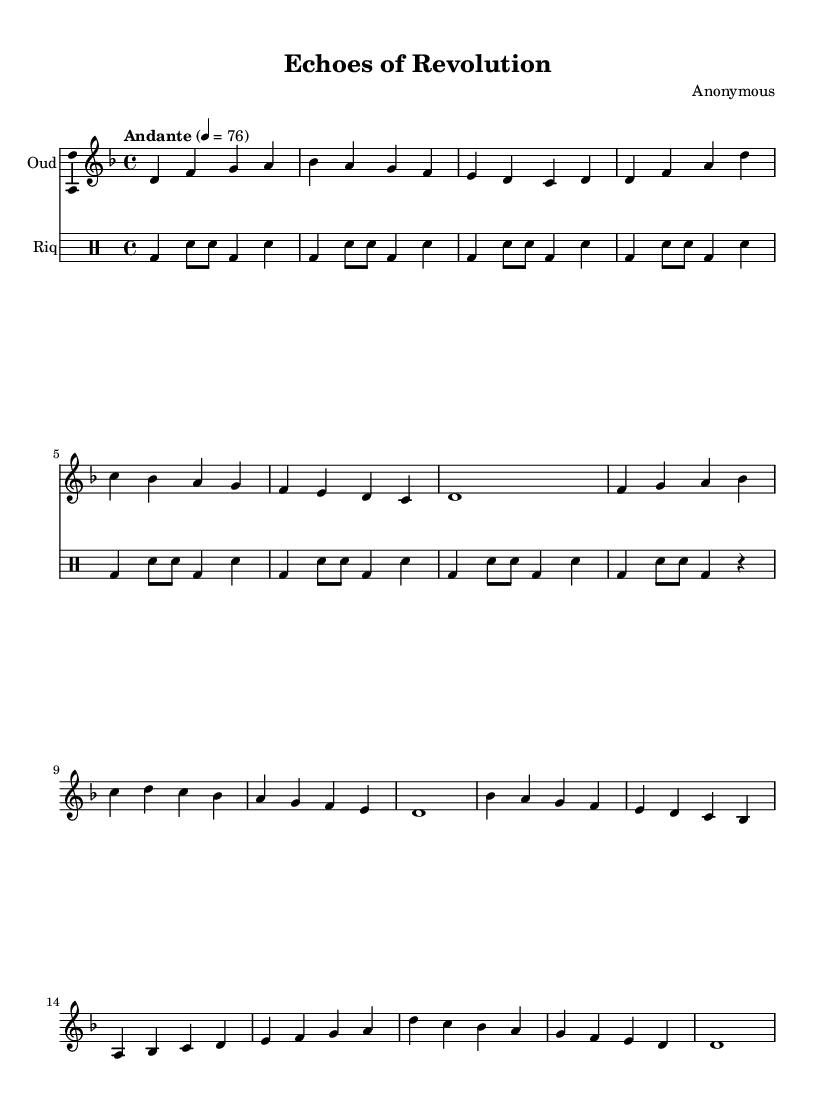What is the key signature of this music? The key signature is D minor, which consists of one flat (B♭). This can be identified by looking at the beginning of the staff where the sharps and flats are indicated.
Answer: D minor What is the time signature of the piece? The time signature is 4/4, which indicates there are four beats in each measure and that the quarter note receives one beat. This is typically shown at the start of the music section.
Answer: 4/4 What is the tempo marking for this piece? The tempo marking says "Andante" with a metronome marking of 76 beats per minute, indicating a leisurely pace. This information is usually found at the beginning of the score above the staff.
Answer: Andante 4 = 76 How many measures are in the verse section? The verse section consists of four measures, as can be seen by counting the individual bar lines in that portion of the sheet music.
Answer: 4 Which instruments are featured in this composition? The featured instruments are the Oud and Riq, as indicated at the beginning of each staff with their corresponding names.
Answer: Oud and Riq What mood or theme does the changing dynamics reflect in this piece? The varied dynamics throughout the piece likely reflect the emotional intensity and changing circumstances of the Arab Spring, with certain sections becoming more intense and others more subdued, aligning with the overall thematic content of protest and hope.
Answer: Emotional intensity How does the structure of the composition reflect traditional Middle Eastern music? The use of repeated motifs and the call-and-response style in the oud part, along with the rhythmic patterns in the Riq, highlights the improvisational nature and cyclical forms characteristic of Middle Eastern music.
Answer: Cyclical form 